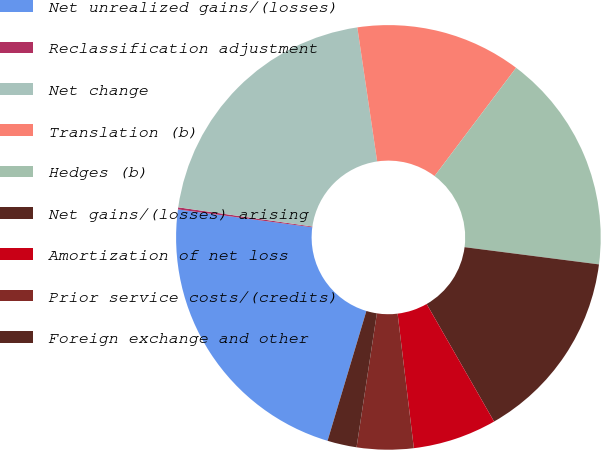<chart> <loc_0><loc_0><loc_500><loc_500><pie_chart><fcel>Net unrealized gains/(losses)<fcel>Reclassification adjustment<fcel>Net change<fcel>Translation (b)<fcel>Hedges (b)<fcel>Net gains/(losses) arising<fcel>Amortization of net loss<fcel>Prior service costs/(credits)<fcel>Foreign exchange and other<nl><fcel>22.48%<fcel>0.16%<fcel>20.4%<fcel>12.61%<fcel>16.76%<fcel>14.68%<fcel>6.38%<fcel>4.31%<fcel>2.23%<nl></chart> 